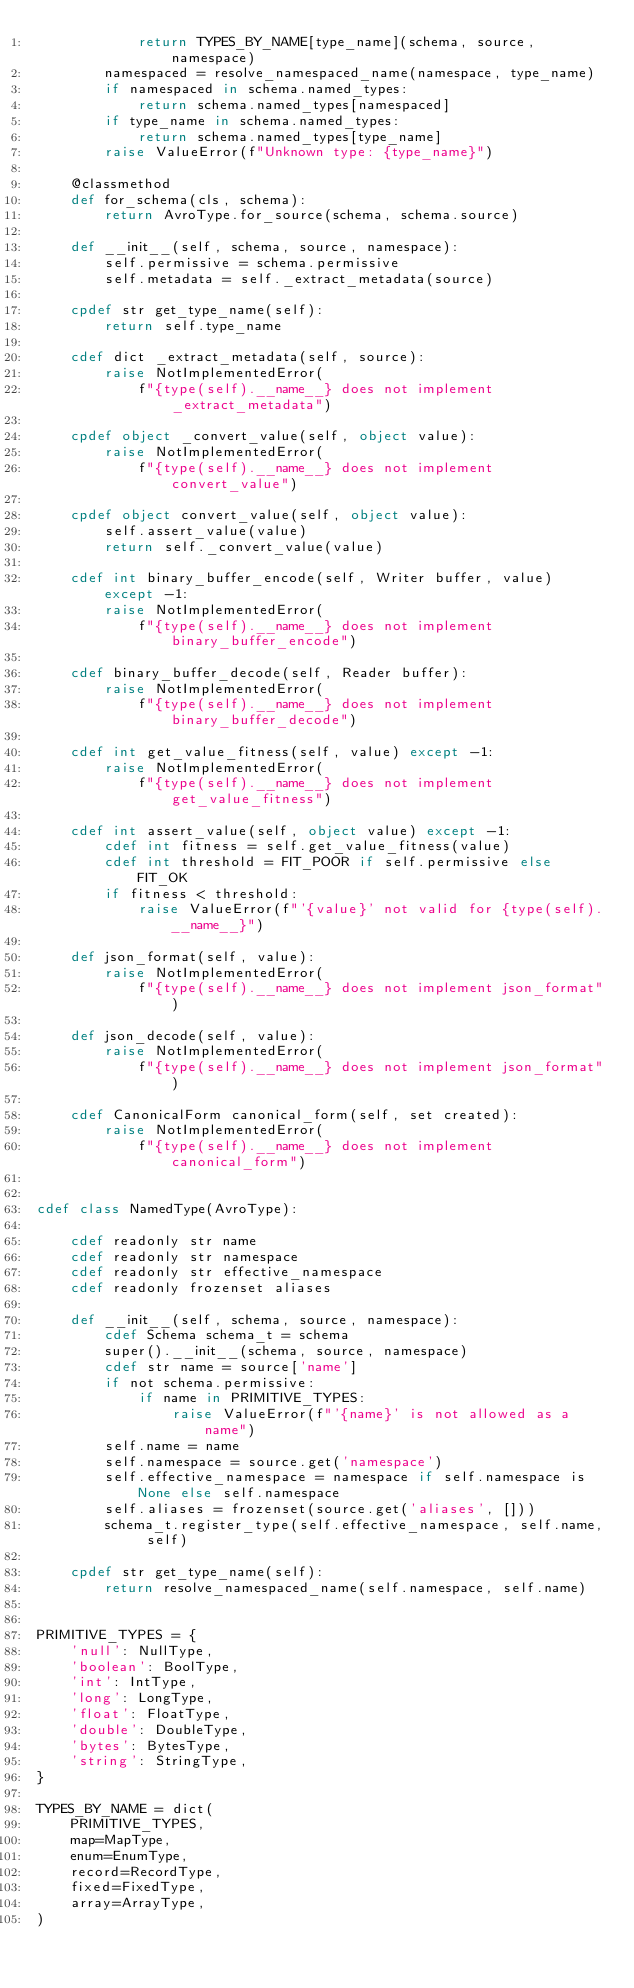<code> <loc_0><loc_0><loc_500><loc_500><_Cython_>            return TYPES_BY_NAME[type_name](schema, source, namespace)
        namespaced = resolve_namespaced_name(namespace, type_name)
        if namespaced in schema.named_types:
            return schema.named_types[namespaced]
        if type_name in schema.named_types:
            return schema.named_types[type_name]
        raise ValueError(f"Unknown type: {type_name}")

    @classmethod
    def for_schema(cls, schema):
        return AvroType.for_source(schema, schema.source)

    def __init__(self, schema, source, namespace):
        self.permissive = schema.permissive
        self.metadata = self._extract_metadata(source)

    cpdef str get_type_name(self):
        return self.type_name

    cdef dict _extract_metadata(self, source):
        raise NotImplementedError(
            f"{type(self).__name__} does not implement _extract_metadata")

    cpdef object _convert_value(self, object value):
        raise NotImplementedError(
            f"{type(self).__name__} does not implement convert_value")

    cpdef object convert_value(self, object value):
        self.assert_value(value)
        return self._convert_value(value)

    cdef int binary_buffer_encode(self, Writer buffer, value) except -1:
        raise NotImplementedError(
            f"{type(self).__name__} does not implement binary_buffer_encode")

    cdef binary_buffer_decode(self, Reader buffer):
        raise NotImplementedError(
            f"{type(self).__name__} does not implement binary_buffer_decode")

    cdef int get_value_fitness(self, value) except -1:
        raise NotImplementedError(
            f"{type(self).__name__} does not implement get_value_fitness")

    cdef int assert_value(self, object value) except -1:
        cdef int fitness = self.get_value_fitness(value)
        cdef int threshold = FIT_POOR if self.permissive else FIT_OK
        if fitness < threshold:
            raise ValueError(f"'{value}' not valid for {type(self).__name__}")

    def json_format(self, value):
        raise NotImplementedError(
            f"{type(self).__name__} does not implement json_format")

    def json_decode(self, value):
        raise NotImplementedError(
            f"{type(self).__name__} does not implement json_format")

    cdef CanonicalForm canonical_form(self, set created):
        raise NotImplementedError(
            f"{type(self).__name__} does not implement canonical_form")


cdef class NamedType(AvroType):

    cdef readonly str name
    cdef readonly str namespace
    cdef readonly str effective_namespace
    cdef readonly frozenset aliases

    def __init__(self, schema, source, namespace):
        cdef Schema schema_t = schema
        super().__init__(schema, source, namespace)
        cdef str name = source['name']
        if not schema.permissive:
            if name in PRIMITIVE_TYPES:
                raise ValueError(f"'{name}' is not allowed as a name")
        self.name = name
        self.namespace = source.get('namespace')
        self.effective_namespace = namespace if self.namespace is None else self.namespace
        self.aliases = frozenset(source.get('aliases', []))
        schema_t.register_type(self.effective_namespace, self.name, self)

    cpdef str get_type_name(self):
        return resolve_namespaced_name(self.namespace, self.name)


PRIMITIVE_TYPES = {
    'null': NullType,
    'boolean': BoolType,
    'int': IntType,
    'long': LongType,
    'float': FloatType,
    'double': DoubleType,
    'bytes': BytesType,
    'string': StringType,
}

TYPES_BY_NAME = dict(
    PRIMITIVE_TYPES,
    map=MapType,
    enum=EnumType,
    record=RecordType,
    fixed=FixedType,
    array=ArrayType,
)
</code> 